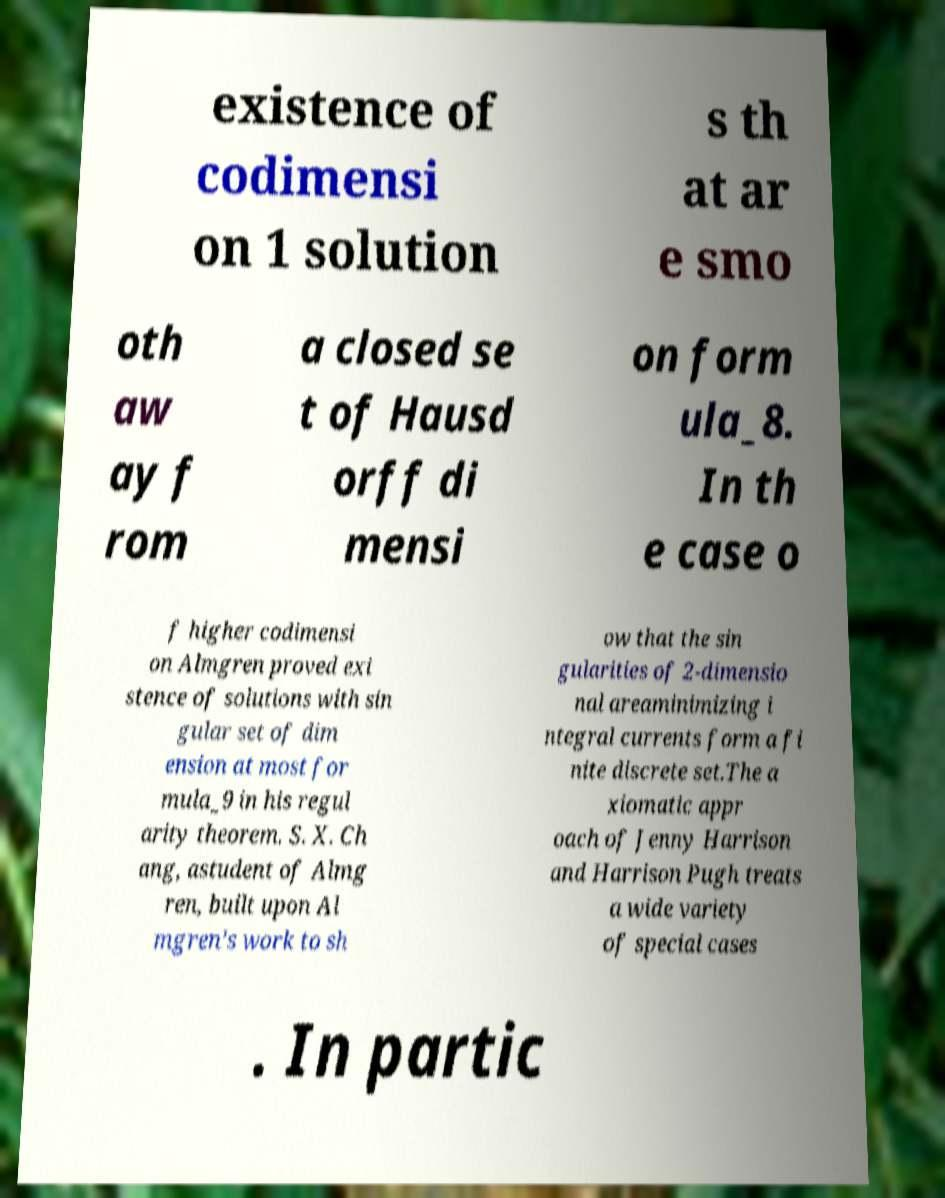For documentation purposes, I need the text within this image transcribed. Could you provide that? existence of codimensi on 1 solution s th at ar e smo oth aw ay f rom a closed se t of Hausd orff di mensi on form ula_8. In th e case o f higher codimensi on Almgren proved exi stence of solutions with sin gular set of dim ension at most for mula_9 in his regul arity theorem. S. X. Ch ang, astudent of Almg ren, built upon Al mgren’s work to sh ow that the sin gularities of 2-dimensio nal areaminimizing i ntegral currents form a fi nite discrete set.The a xiomatic appr oach of Jenny Harrison and Harrison Pugh treats a wide variety of special cases . In partic 